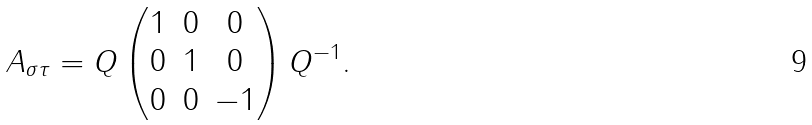Convert formula to latex. <formula><loc_0><loc_0><loc_500><loc_500>A _ { \sigma \tau } = Q \begin{pmatrix} 1 & 0 & 0 \\ 0 & 1 & 0 \\ 0 & 0 & - 1 \end{pmatrix} Q ^ { - 1 } .</formula> 